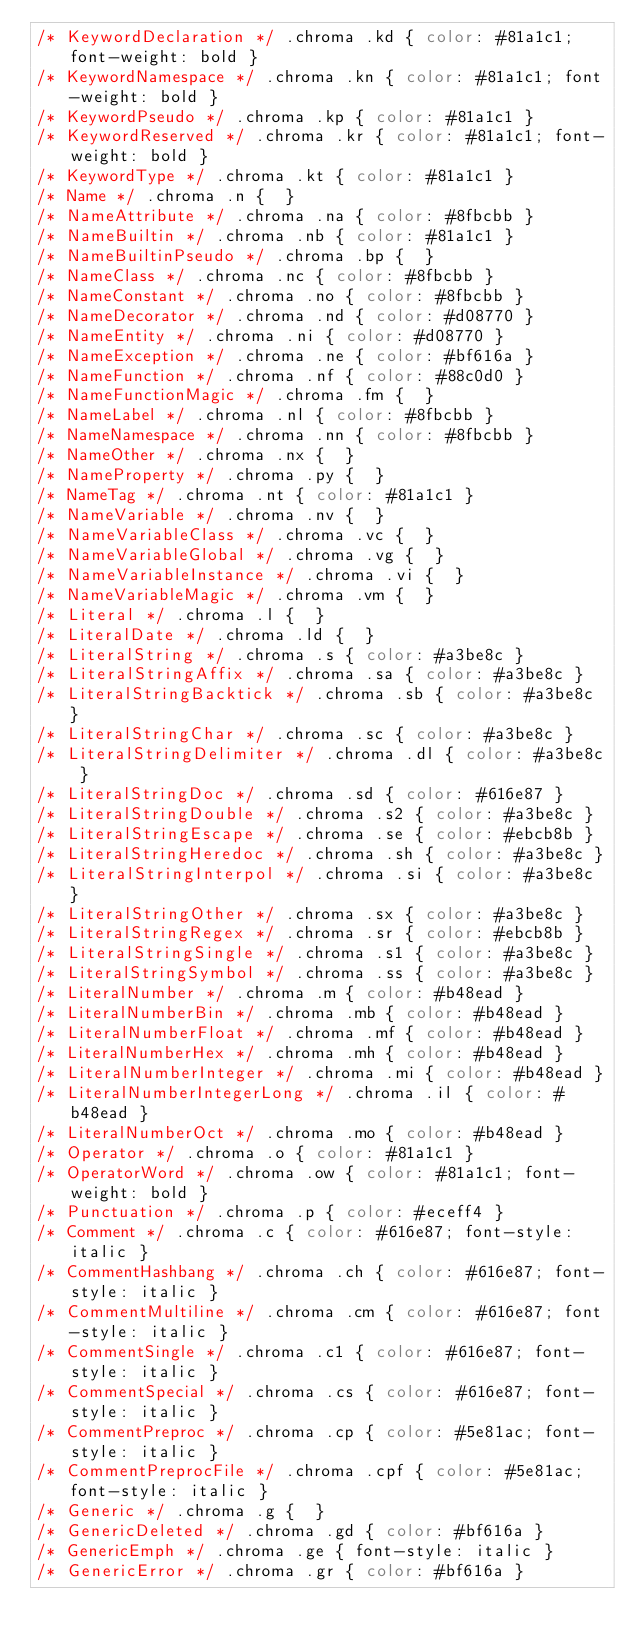Convert code to text. <code><loc_0><loc_0><loc_500><loc_500><_CSS_>/* KeywordDeclaration */ .chroma .kd { color: #81a1c1; font-weight: bold }
/* KeywordNamespace */ .chroma .kn { color: #81a1c1; font-weight: bold }
/* KeywordPseudo */ .chroma .kp { color: #81a1c1 }
/* KeywordReserved */ .chroma .kr { color: #81a1c1; font-weight: bold }
/* KeywordType */ .chroma .kt { color: #81a1c1 }
/* Name */ .chroma .n {  }
/* NameAttribute */ .chroma .na { color: #8fbcbb }
/* NameBuiltin */ .chroma .nb { color: #81a1c1 }
/* NameBuiltinPseudo */ .chroma .bp {  }
/* NameClass */ .chroma .nc { color: #8fbcbb }
/* NameConstant */ .chroma .no { color: #8fbcbb }
/* NameDecorator */ .chroma .nd { color: #d08770 }
/* NameEntity */ .chroma .ni { color: #d08770 }
/* NameException */ .chroma .ne { color: #bf616a }
/* NameFunction */ .chroma .nf { color: #88c0d0 }
/* NameFunctionMagic */ .chroma .fm {  }
/* NameLabel */ .chroma .nl { color: #8fbcbb }
/* NameNamespace */ .chroma .nn { color: #8fbcbb }
/* NameOther */ .chroma .nx {  }
/* NameProperty */ .chroma .py {  }
/* NameTag */ .chroma .nt { color: #81a1c1 }
/* NameVariable */ .chroma .nv {  }
/* NameVariableClass */ .chroma .vc {  }
/* NameVariableGlobal */ .chroma .vg {  }
/* NameVariableInstance */ .chroma .vi {  }
/* NameVariableMagic */ .chroma .vm {  }
/* Literal */ .chroma .l {  }
/* LiteralDate */ .chroma .ld {  }
/* LiteralString */ .chroma .s { color: #a3be8c }
/* LiteralStringAffix */ .chroma .sa { color: #a3be8c }
/* LiteralStringBacktick */ .chroma .sb { color: #a3be8c }
/* LiteralStringChar */ .chroma .sc { color: #a3be8c }
/* LiteralStringDelimiter */ .chroma .dl { color: #a3be8c }
/* LiteralStringDoc */ .chroma .sd { color: #616e87 }
/* LiteralStringDouble */ .chroma .s2 { color: #a3be8c }
/* LiteralStringEscape */ .chroma .se { color: #ebcb8b }
/* LiteralStringHeredoc */ .chroma .sh { color: #a3be8c }
/* LiteralStringInterpol */ .chroma .si { color: #a3be8c }
/* LiteralStringOther */ .chroma .sx { color: #a3be8c }
/* LiteralStringRegex */ .chroma .sr { color: #ebcb8b }
/* LiteralStringSingle */ .chroma .s1 { color: #a3be8c }
/* LiteralStringSymbol */ .chroma .ss { color: #a3be8c }
/* LiteralNumber */ .chroma .m { color: #b48ead }
/* LiteralNumberBin */ .chroma .mb { color: #b48ead }
/* LiteralNumberFloat */ .chroma .mf { color: #b48ead }
/* LiteralNumberHex */ .chroma .mh { color: #b48ead }
/* LiteralNumberInteger */ .chroma .mi { color: #b48ead }
/* LiteralNumberIntegerLong */ .chroma .il { color: #b48ead }
/* LiteralNumberOct */ .chroma .mo { color: #b48ead }
/* Operator */ .chroma .o { color: #81a1c1 }
/* OperatorWord */ .chroma .ow { color: #81a1c1; font-weight: bold }
/* Punctuation */ .chroma .p { color: #eceff4 }
/* Comment */ .chroma .c { color: #616e87; font-style: italic }
/* CommentHashbang */ .chroma .ch { color: #616e87; font-style: italic }
/* CommentMultiline */ .chroma .cm { color: #616e87; font-style: italic }
/* CommentSingle */ .chroma .c1 { color: #616e87; font-style: italic }
/* CommentSpecial */ .chroma .cs { color: #616e87; font-style: italic }
/* CommentPreproc */ .chroma .cp { color: #5e81ac; font-style: italic }
/* CommentPreprocFile */ .chroma .cpf { color: #5e81ac; font-style: italic }
/* Generic */ .chroma .g {  }
/* GenericDeleted */ .chroma .gd { color: #bf616a }
/* GenericEmph */ .chroma .ge { font-style: italic }
/* GenericError */ .chroma .gr { color: #bf616a }</code> 